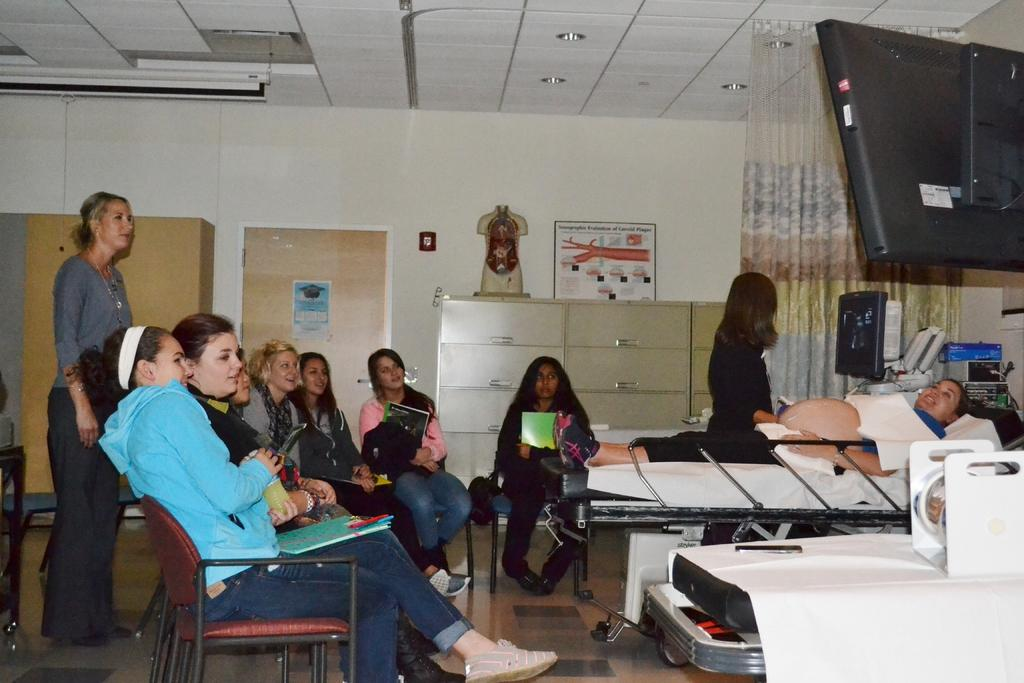What are the lady persons in the image doing? There is a group of lady persons sitting, two lady persons standing, and one lady person lying on a bed in the image. Can you describe the position of the lady person on the bed? The lady person on the bed is lying down. What is located at the top right of the image? There is a screen at the top right of the image. How many boys are flying kites in the image? There are no boys or kites present in the image. What color is the tongue of the lady person lying on the bed? There is no mention of a tongue in the image, as it is not visible or relevant to the provided facts. 